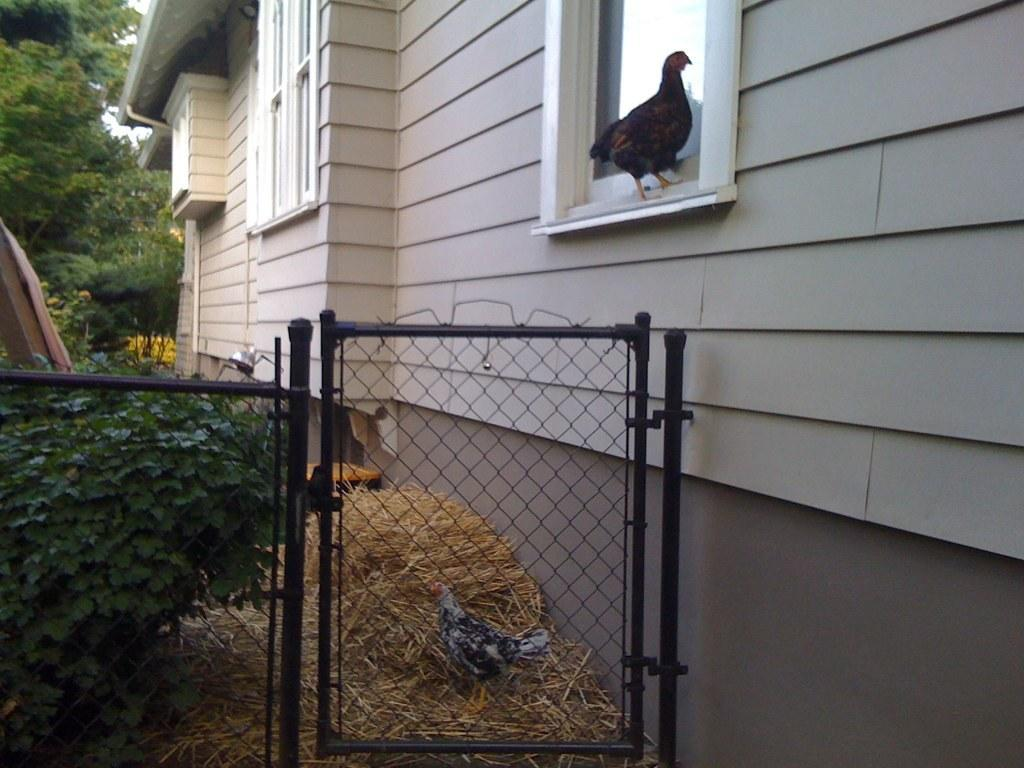What type of structure can be seen in the image? There is a gate in the image. What material is used for the gate? The gate has mesh in the image. What animals are present in the image? There are hens in the image. What object is visible in the image? There is a box in the image. What type of ground cover is present in the image? There is dried grass in the image. What type of vegetation is present in the image? There are plants in the image. What type of background can be seen in the image? There is a wall in the image, and trees and sky are visible in the background. What architectural feature is present in the image? There are windows in the image. Can you tell me how many caves are visible in the image? There are no caves present in the image. What type of mountain can be seen in the background of the image? There are no mountains present in the image; only trees and sky are visible in the background. 